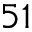Convert formula to latex. <formula><loc_0><loc_0><loc_500><loc_500>5 1</formula> 